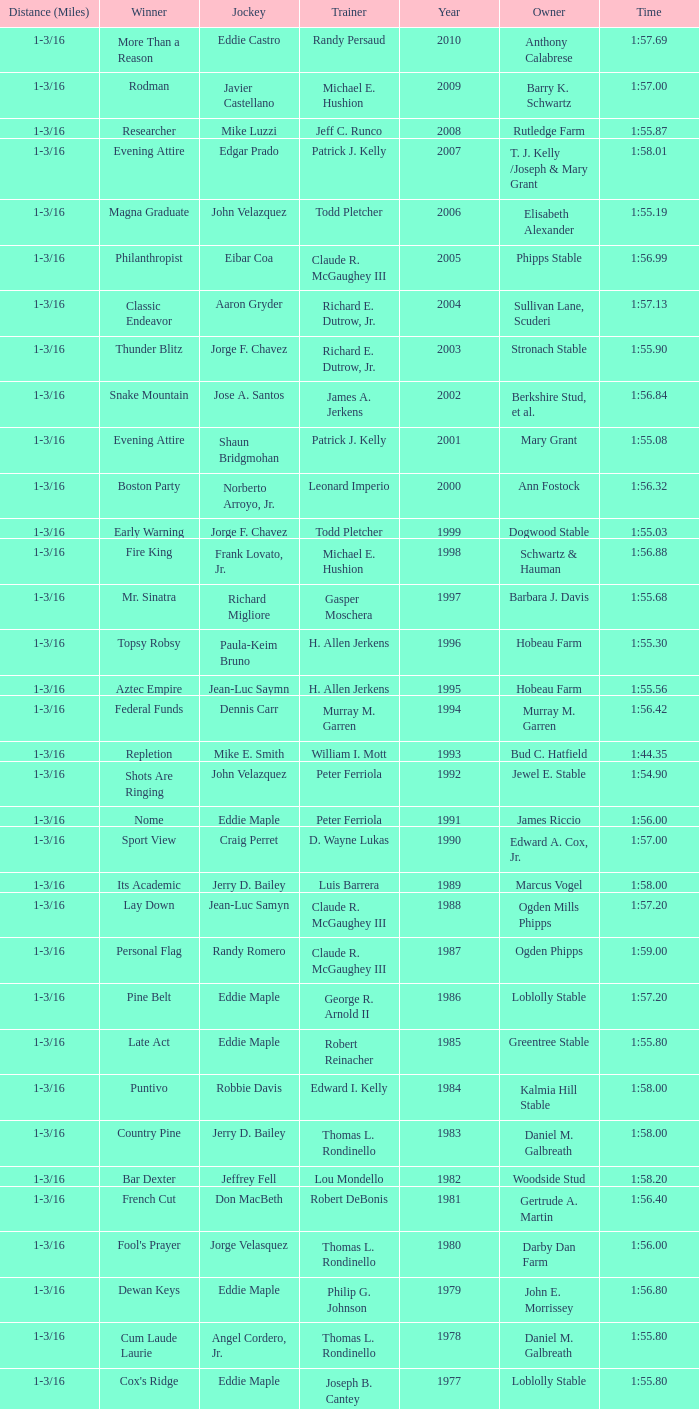What was the time for the winning horse Salford ii? 1:44.20. Could you help me parse every detail presented in this table? {'header': ['Distance (Miles)', 'Winner', 'Jockey', 'Trainer', 'Year', 'Owner', 'Time'], 'rows': [['1-3/16', 'More Than a Reason', 'Eddie Castro', 'Randy Persaud', '2010', 'Anthony Calabrese', '1:57.69'], ['1-3/16', 'Rodman', 'Javier Castellano', 'Michael E. Hushion', '2009', 'Barry K. Schwartz', '1:57.00'], ['1-3/16', 'Researcher', 'Mike Luzzi', 'Jeff C. Runco', '2008', 'Rutledge Farm', '1:55.87'], ['1-3/16', 'Evening Attire', 'Edgar Prado', 'Patrick J. Kelly', '2007', 'T. J. Kelly /Joseph & Mary Grant', '1:58.01'], ['1-3/16', 'Magna Graduate', 'John Velazquez', 'Todd Pletcher', '2006', 'Elisabeth Alexander', '1:55.19'], ['1-3/16', 'Philanthropist', 'Eibar Coa', 'Claude R. McGaughey III', '2005', 'Phipps Stable', '1:56.99'], ['1-3/16', 'Classic Endeavor', 'Aaron Gryder', 'Richard E. Dutrow, Jr.', '2004', 'Sullivan Lane, Scuderi', '1:57.13'], ['1-3/16', 'Thunder Blitz', 'Jorge F. Chavez', 'Richard E. Dutrow, Jr.', '2003', 'Stronach Stable', '1:55.90'], ['1-3/16', 'Snake Mountain', 'Jose A. Santos', 'James A. Jerkens', '2002', 'Berkshire Stud, et al.', '1:56.84'], ['1-3/16', 'Evening Attire', 'Shaun Bridgmohan', 'Patrick J. Kelly', '2001', 'Mary Grant', '1:55.08'], ['1-3/16', 'Boston Party', 'Norberto Arroyo, Jr.', 'Leonard Imperio', '2000', 'Ann Fostock', '1:56.32'], ['1-3/16', 'Early Warning', 'Jorge F. Chavez', 'Todd Pletcher', '1999', 'Dogwood Stable', '1:55.03'], ['1-3/16', 'Fire King', 'Frank Lovato, Jr.', 'Michael E. Hushion', '1998', 'Schwartz & Hauman', '1:56.88'], ['1-3/16', 'Mr. Sinatra', 'Richard Migliore', 'Gasper Moschera', '1997', 'Barbara J. Davis', '1:55.68'], ['1-3/16', 'Topsy Robsy', 'Paula-Keim Bruno', 'H. Allen Jerkens', '1996', 'Hobeau Farm', '1:55.30'], ['1-3/16', 'Aztec Empire', 'Jean-Luc Saymn', 'H. Allen Jerkens', '1995', 'Hobeau Farm', '1:55.56'], ['1-3/16', 'Federal Funds', 'Dennis Carr', 'Murray M. Garren', '1994', 'Murray M. Garren', '1:56.42'], ['1-3/16', 'Repletion', 'Mike E. Smith', 'William I. Mott', '1993', 'Bud C. Hatfield', '1:44.35'], ['1-3/16', 'Shots Are Ringing', 'John Velazquez', 'Peter Ferriola', '1992', 'Jewel E. Stable', '1:54.90'], ['1-3/16', 'Nome', 'Eddie Maple', 'Peter Ferriola', '1991', 'James Riccio', '1:56.00'], ['1-3/16', 'Sport View', 'Craig Perret', 'D. Wayne Lukas', '1990', 'Edward A. Cox, Jr.', '1:57.00'], ['1-3/16', 'Its Academic', 'Jerry D. Bailey', 'Luis Barrera', '1989', 'Marcus Vogel', '1:58.00'], ['1-3/16', 'Lay Down', 'Jean-Luc Samyn', 'Claude R. McGaughey III', '1988', 'Ogden Mills Phipps', '1:57.20'], ['1-3/16', 'Personal Flag', 'Randy Romero', 'Claude R. McGaughey III', '1987', 'Ogden Phipps', '1:59.00'], ['1-3/16', 'Pine Belt', 'Eddie Maple', 'George R. Arnold II', '1986', 'Loblolly Stable', '1:57.20'], ['1-3/16', 'Late Act', 'Eddie Maple', 'Robert Reinacher', '1985', 'Greentree Stable', '1:55.80'], ['1-3/16', 'Puntivo', 'Robbie Davis', 'Edward I. Kelly', '1984', 'Kalmia Hill Stable', '1:58.00'], ['1-3/16', 'Country Pine', 'Jerry D. Bailey', 'Thomas L. Rondinello', '1983', 'Daniel M. Galbreath', '1:58.00'], ['1-3/16', 'Bar Dexter', 'Jeffrey Fell', 'Lou Mondello', '1982', 'Woodside Stud', '1:58.20'], ['1-3/16', 'French Cut', 'Don MacBeth', 'Robert DeBonis', '1981', 'Gertrude A. Martin', '1:56.40'], ['1-3/16', "Fool's Prayer", 'Jorge Velasquez', 'Thomas L. Rondinello', '1980', 'Darby Dan Farm', '1:56.00'], ['1-3/16', 'Dewan Keys', 'Eddie Maple', 'Philip G. Johnson', '1979', 'John E. Morrissey', '1:56.80'], ['1-3/16', 'Cum Laude Laurie', 'Angel Cordero, Jr.', 'Thomas L. Rondinello', '1978', 'Daniel M. Galbreath', '1:55.80'], ['1-3/16', "Cox's Ridge", 'Eddie Maple', 'Joseph B. Cantey', '1977', 'Loblolly Stable', '1:55.80'], ['1-3/16', "It's Freezing", 'Jacinto Vasquez', 'Anthony Basile', '1976', 'Bwamazon Farm', '1:56.60'], ['1-3/16', 'Hail The Pirates', 'Ron Turcotte', 'Thomas L. Rondinello', '1975', 'Daniel M. Galbreath', '1:55.60'], ['1-3/16', 'Free Hand', 'Jose Amy', 'Pancho Martin', '1974', 'Sigmund Sommer', '1:55.00'], ['1-3/16', 'True Knight', 'Angel Cordero, Jr.', 'Thomas L. Rondinello', '1973', 'Darby Dan Farm', '1:55.00'], ['1-3/16', 'Sunny And Mild', 'Michael Venezia', 'W. Preston King', '1972', 'Harry Rogosin', '1:54.40'], ['1-1/8', 'Red Reality', 'Jorge Velasquez', 'MacKenzie Miller', '1971', 'Cragwood Stables', '1:49.60'], ['1-1/8', 'Best Turn', 'Larry Adams', 'Reggie Cornell', '1970', 'Calumet Farm', '1:50.00'], ['1-1/8', 'Vif', 'Larry Adams', 'Clarence Meaux', '1969', 'Harvey Peltier', '1:49.20'], ['1-1/8', 'Irish Dude', 'Sandino Hernandez', 'Jack Bradley', '1968', 'Richard W. Taylor', '1:49.60'], ['1-1/8', 'Mr. Right', 'Heliodoro Gustines', 'Evan S. Jackson', '1967', 'Mrs. Peter Duchin', '1:49.60'], ['1-1/8', 'Amberoid', 'Walter Blum', 'Lucien Laurin', '1966', 'Reginald N. Webster', '1:50.60'], ['1-1/8', 'Prairie Schooner', 'Eddie Belmonte', 'James W. Smith', '1965', 'High Tide Stable', '1:50.20'], ['1-1/8', 'Third Martini', 'William Boland', 'H. Allen Jerkens', '1964', 'Hobeau Farm', '1:50.60'], ['1-1/8', 'Uppercut', 'Manuel Ycaza', 'Willard C. Freeman', '1963', 'William Harmonay', '1:35.40'], ['1 mile', 'Grid Iron Hero', 'Manuel Ycaza', 'Laz Barrera', '1962', 'Emil Dolce', '1:34.00'], ['1 mile', 'Manassa Mauler', 'Braulio Baeza', 'Pancho Martin', '1961', 'Emil Dolce', '1:36.20'], ['1 mile', 'Cranberry Sauce', 'Heliodoro Gustines', 'not found', '1960', 'Elmendorf Farm', '1:36.20'], ['1 mile', 'Whitley', 'Eric Guerin', 'Max Hirsch', '1959', 'W. Arnold Hanger', '1:36.40'], ['1-1/16', 'Oh Johnny', 'William Boland', 'Norman R. McLeod', '1958', 'Mrs. Wallace Gilroy', '1:43.40'], ['1-1/16', 'Bold Ruler', 'Eddie Arcaro', 'James E. Fitzsimmons', '1957', 'Wheatley Stable', '1:42.80'], ['1-1/16', 'Blessbull', 'Willie Lester', 'not found', '1956', 'Morris Sims', '1:42.00'], ['1-1/16', 'Fabulist', 'Ted Atkinson', 'William C. Winfrey', '1955', 'High Tide Stable', '1:43.60'], ['1-1/16', 'Find', 'Eric Guerin', 'William C. Winfrey', '1954', 'Alfred G. Vanderbilt II', '1:44.00'], ['1-1/16', 'Flaunt', 'S. Cole', 'Hubert W. Williams', '1953', 'Arnold Skjeveland', '1:44.20'], ['1-1/16', 'County Delight', 'Dave Gorman', 'James E. Ryan', '1952', 'Rokeby Stable', '1:43.60'], ['1-1/16', 'Sheilas Reward', 'Ovie Scurlock', 'Eugene Jacobs', '1951', 'Mrs. Louis Lazare', '1:44.60'], ['1-1/16', 'Three Rings', 'Hedley Woodhouse', 'Willie Knapp', '1950', 'Mrs. Evelyn L. Hopkins', '1:44.60'], ['1-1/16', 'Three Rings', 'Ted Atkinson', 'Willie Knapp', '1949', 'Mrs. Evelyn L. Hopkins', '1:47.40'], ['1-1/16', 'Knockdown', 'Ferrill Zufelt', 'Tom Smith', '1948', 'Maine Chance Farm', '1:44.60'], ['1-1/16', 'Gallorette', 'Job Dean Jessop', 'Edward A. Christmas', '1947', 'William L. Brann', '1:45.40'], ['1-1/16', 'Helioptic', 'Paul Miller', 'not found', '1946', 'William Goadby Loew', '1:43.20'], ['1-1/16', 'Olympic Zenith', 'Conn McCreary', 'Willie Booth', '1945', 'William G. Helis', '1:45.60'], ['1-1/16', 'First Fiddle', 'Johnny Longden', 'Edward Mulrenan', '1944', 'Mrs. Edward Mulrenan', '1:44.20'], ['1-1/16', 'The Rhymer', 'Conn McCreary', 'John M. Gaver, Sr.', '1943', 'Greentree Stable', '1:45.00'], ['1-1/16', 'Waller', 'Billie Thompson', 'A. G. Robertson', '1942', 'John C. Clark', '1:44.00'], ['1-1/16', 'Salford II', 'Don Meade', 'not found', '1941', 'Ralph B. Strassburger', '1:44.20'], ['1-1/16', 'He Did', 'Eddie Arcaro', 'J. Thomas Taylor', '1940', 'W. Arnold Hanger', '1:43.20'], ['1 mile', 'Lovely Night', 'Johnny Longden', 'Henry McDaniel', '1939', 'Mrs. F. Ambrose Clark', '1:36.40'], ['1 mile', 'War Admiral', 'Charles Kurtsinger', 'George Conway', '1938', 'Glen Riddle Farm', '1:36.80'], ['1 mile', 'Snark', 'Johnny Longden', 'James E. Fitzsimmons', '1937', 'Wheatley Stable', '1:37.40'], ['1 mile', 'Good Gamble', 'Samuel Renick', 'Bud Stotler', '1936', 'Alfred G. Vanderbilt II', '1:37.20'], ['1 mile', 'King Saxon', 'Calvin Rainey', 'Charles Shaw', '1935', 'C. H. Knebelkamp', '1:37.20'], ['1 mile', 'Singing Wood', 'Robert Jones', 'James W. Healy', '1934', 'Liz Whitney', '1:38.60'], ['1 mile', 'Kerry Patch', 'Robert Wholey', 'Joseph A. Notter', '1933', 'Lee Rosenberg', '1:38.00'], ['1 mile', 'Halcyon', 'Hank Mills', 'T. J. Healey', '1932', 'C. V. Whitney', '1:38.00'], ['1 mile', 'Halcyon', 'G. Rose', 'T. J. Healey', '1931', 'C. V. Whitney', '1:38.40'], ['1 mile', 'Kildare', 'John Passero', 'Norman Tallman', '1930', 'Newtondale Stable', '1:38.60'], ['1 mile', 'Comstockery', 'Sidney Hebert', 'Thomas W. Murphy', '1929', 'Greentree Stable', '1:39.60'], ['1 mile', 'Kentucky II', 'George Schreiner', 'Max Hirsch', '1928', 'A. Charles Schwartz', '1:38.80'], ['1 mile', 'Light Carbine', 'James McCoy', 'M. J. Dunlevy', '1927', 'I. B. Humphreys', '1:36.80'], ['1 mile', 'Macaw', 'Linus McAtee', 'James G. Rowe, Sr.', '1926', 'Harry Payne Whitney', '1:37.00'], ['1 mile', 'Mad Play', 'Laverne Fator', 'Sam Hildreth', '1925', 'Rancocas Stable', '1:36.60'], ['1 mile', 'Mad Hatter', 'Earl Sande', 'Sam Hildreth', '1924', 'Rancocas Stable', '1:36.60'], ['1 mile', 'Zev', 'Earl Sande', 'Sam Hildreth', '1923', 'Rancocas Stable', '1:37.00'], ['1 mile', 'Grey Lag', 'Laverne Fator', 'Sam Hildreth', '1922', 'Rancocas Stable', '1:38.00'], ['1 mile', 'John P. Grier', 'Frank Keogh', 'James G. Rowe, Sr.', '1921', 'Harry Payne Whitney', '1:36.00'], ['1 mile', 'Cirrus', 'Lavelle Ensor', 'Sam Hildreth', '1920', 'Sam Hildreth', '1:38.00'], ['1 mile', 'Star Master', 'Merritt Buxton', 'Walter B. Jennings', '1919', 'A. Kingsley Macomber', '1:37.60'], ['1 mile', 'Roamer', 'Lawrence Lyke', 'A. J. Goldsborough', '1918', 'Andrew Miller', '1:36.60'], ['1 mile', 'Old Rosebud', 'Frank Robinson', 'Frank D. Weir', '1917', 'F. D. Weir & Hamilton C. Applegate', '1:37.60'], ['1 mile', 'Short Grass', 'Frank Keogh', 'not found', '1916', 'Emil Herz', '1:36.40'], ['1 mile', 'Roamer', 'James Butwell', 'A. J. Goldsborough', '1915', 'Andrew Miller', '1:39.20'], ['1 mile', 'Flying Fairy', 'Tommy Davies', 'J. Simon Healy', '1914', 'Edward B. Cassatt', '1:42.20'], ['1 mile', 'No Race', 'No Race', 'No Race', '1913', 'No Race', 'no race'], ['1 mile', 'No Race', 'No Race', 'No Race', '1912', 'No Race', 'no race'], ['1 mile', 'No Race', 'No Race', 'No Race', '1911', 'No Race', 'no race'], ['1 mile', 'Arasee', 'Buddy Glass', 'Andrew G. Blakely', '1910', 'Samuel Emery', '1:39.80'], ['1 mile', 'No Race', 'No Race', 'No Race', '1909', 'No Race', 'no race'], ['1 mile', 'Jack Atkin', 'Phil Musgrave', 'Herman R. Brandt', '1908', 'Barney Schreiber', '1:39.00'], ['1 mile', 'W. H. Carey', 'George Mountain', 'James Blute', '1907', 'Richard F. Carman', '1:40.00'], ['1 mile', "Ram's Horn", 'L. Perrine', 'W. S. "Jim" Williams', '1906', 'W. S. "Jim" Williams', '1:39.40'], ['1 mile', 'St. Valentine', 'William Crimmins', 'John Shields', '1905', 'Alexander Shields', '1:39.20'], ['1 mile', 'Rosetint', 'Thomas H. Burns', 'James Boden', '1904', 'John Boden', '1:39.20'], ['1m 70yds', 'Yellow Tail', 'Willie Shaw', 'H. E. Rowell', '1903', 'John Hackett', '1:45.20'], ['1m 70 yds', 'Margravite', 'Otto Wonderly', 'not found', '1902', 'Charles Fleischmann Sons', '1:46.00']]} 